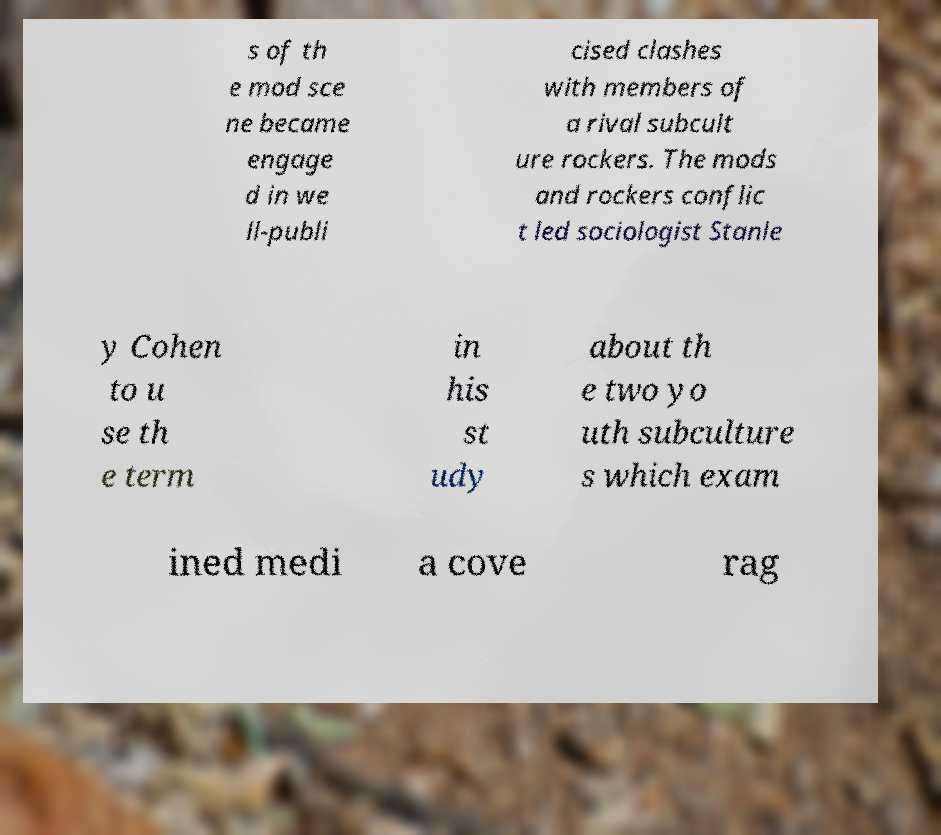I need the written content from this picture converted into text. Can you do that? s of th e mod sce ne became engage d in we ll-publi cised clashes with members of a rival subcult ure rockers. The mods and rockers conflic t led sociologist Stanle y Cohen to u se th e term in his st udy about th e two yo uth subculture s which exam ined medi a cove rag 